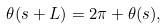Convert formula to latex. <formula><loc_0><loc_0><loc_500><loc_500>\theta ( s + L ) = 2 \pi + \theta ( s ) ,</formula> 